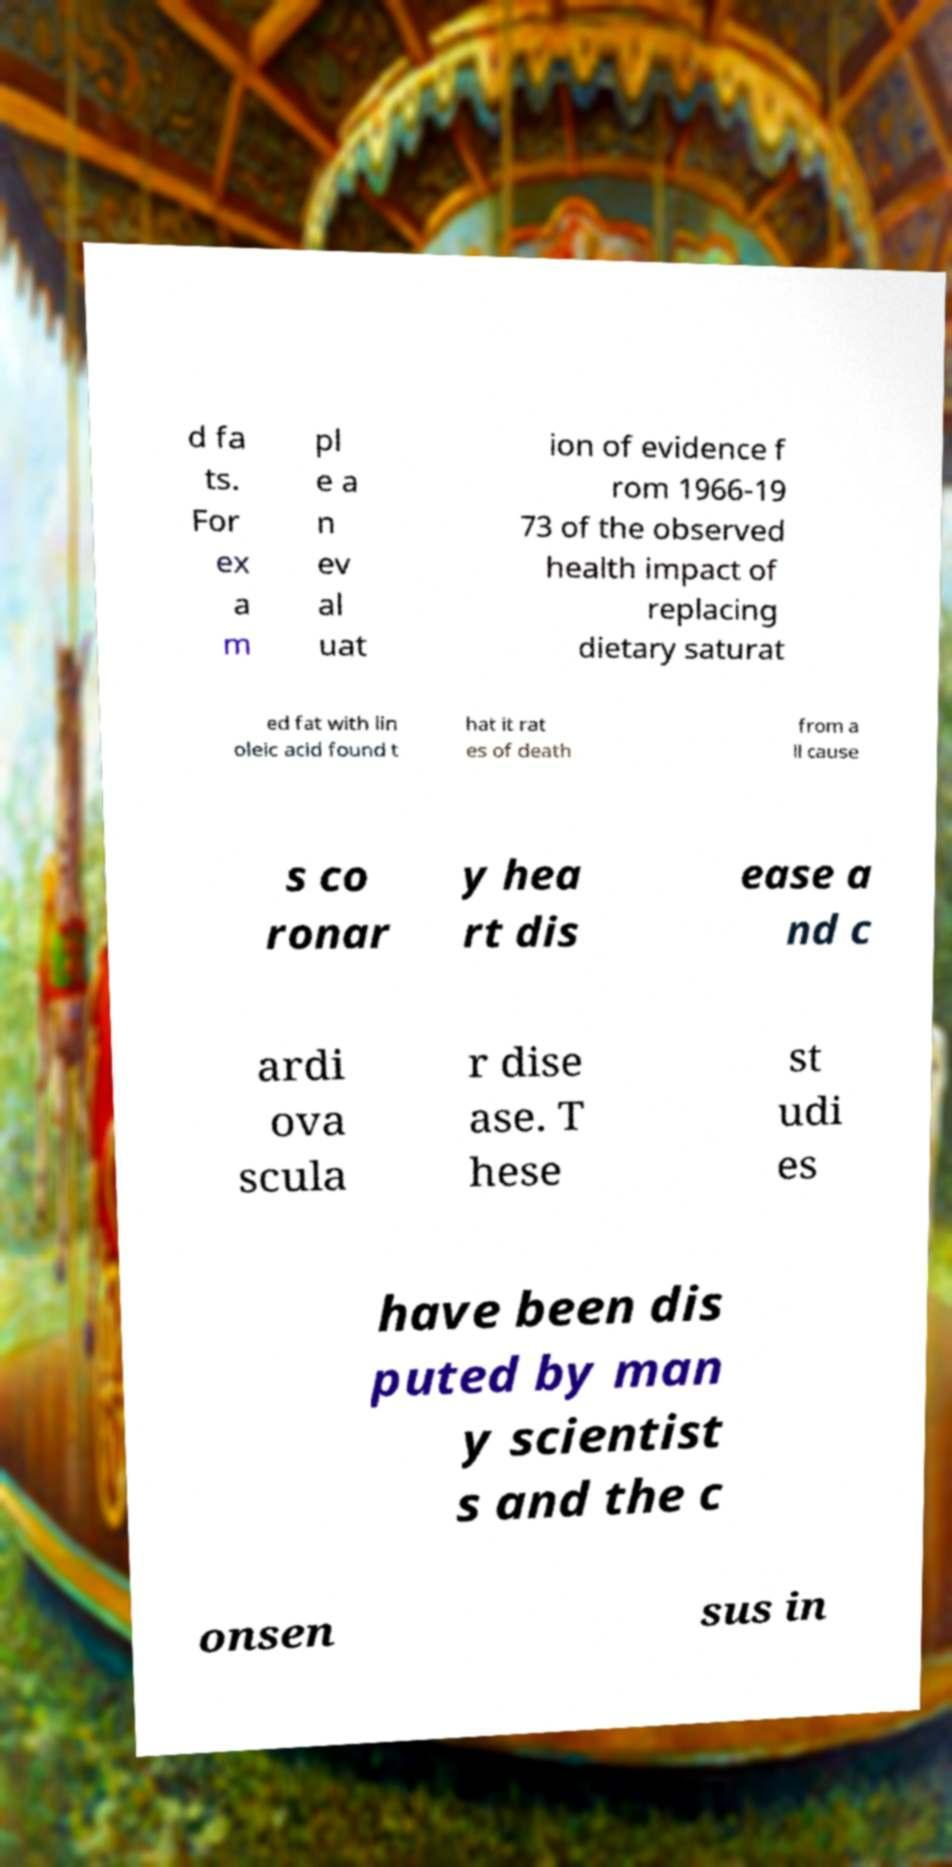I need the written content from this picture converted into text. Can you do that? d fa ts. For ex a m pl e a n ev al uat ion of evidence f rom 1966-19 73 of the observed health impact of replacing dietary saturat ed fat with lin oleic acid found t hat it rat es of death from a ll cause s co ronar y hea rt dis ease a nd c ardi ova scula r dise ase. T hese st udi es have been dis puted by man y scientist s and the c onsen sus in 